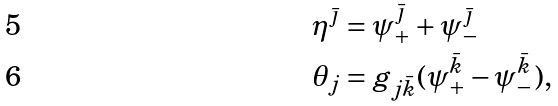Convert formula to latex. <formula><loc_0><loc_0><loc_500><loc_500>\eta ^ { \bar { \jmath } } & = \psi _ { + } ^ { \bar { \jmath } } + \psi _ { - } ^ { \bar { \jmath } } \\ \theta _ { j } & = g _ { j \bar { k } } ( \psi _ { + } ^ { \bar { k } } - \psi _ { - } ^ { \bar { k } } ) ,</formula> 